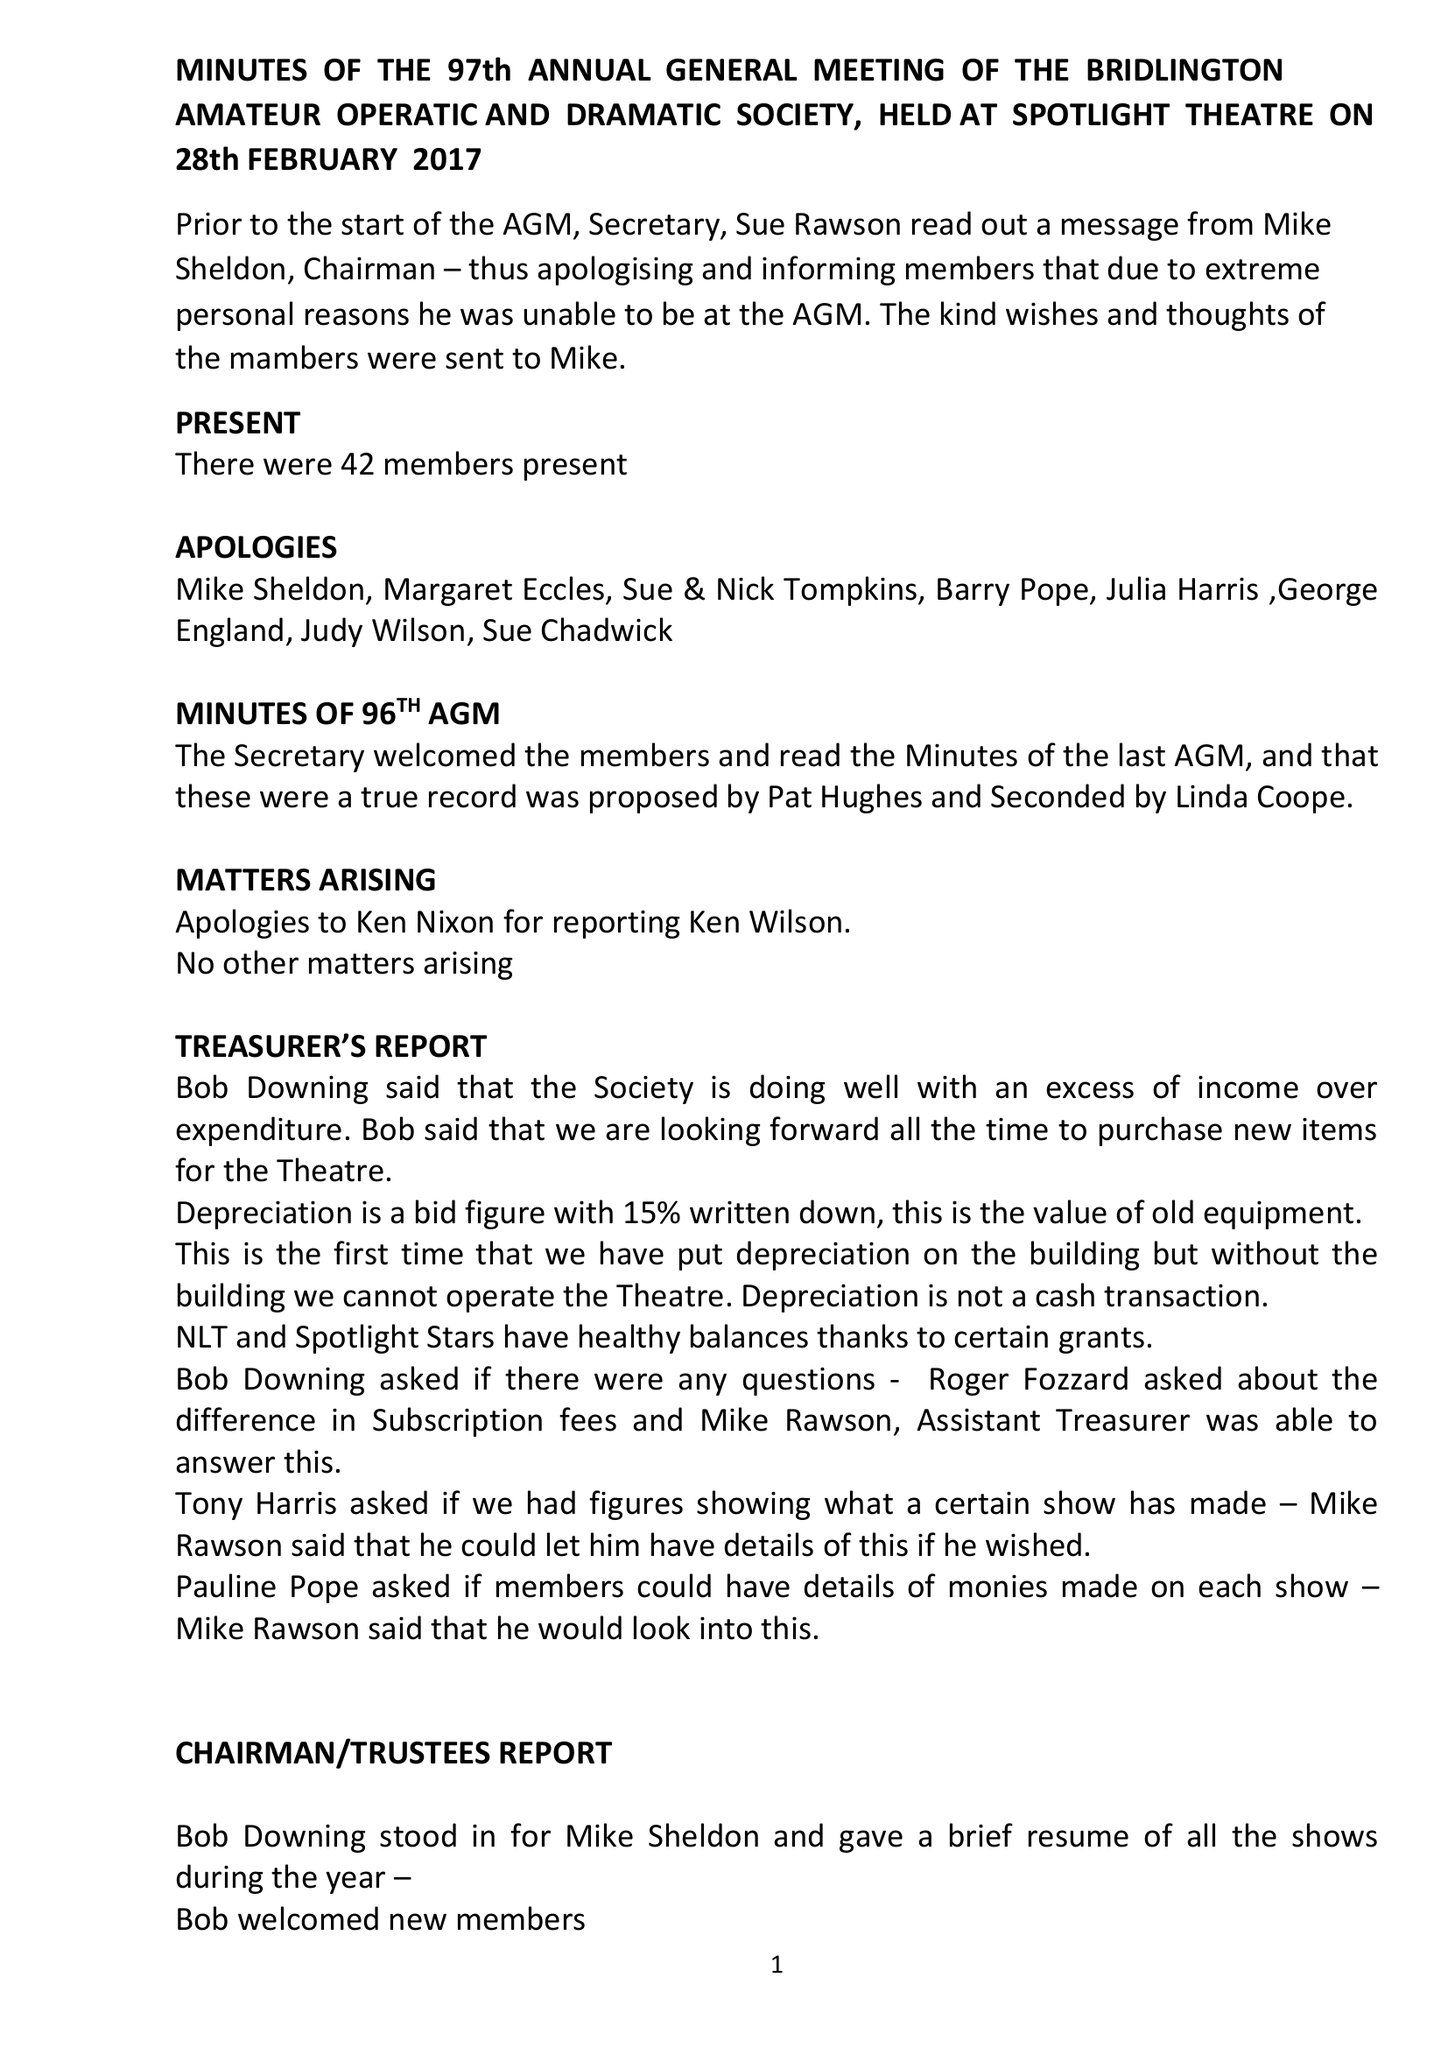What is the value for the spending_annually_in_british_pounds?
Answer the question using a single word or phrase. 65352.00 